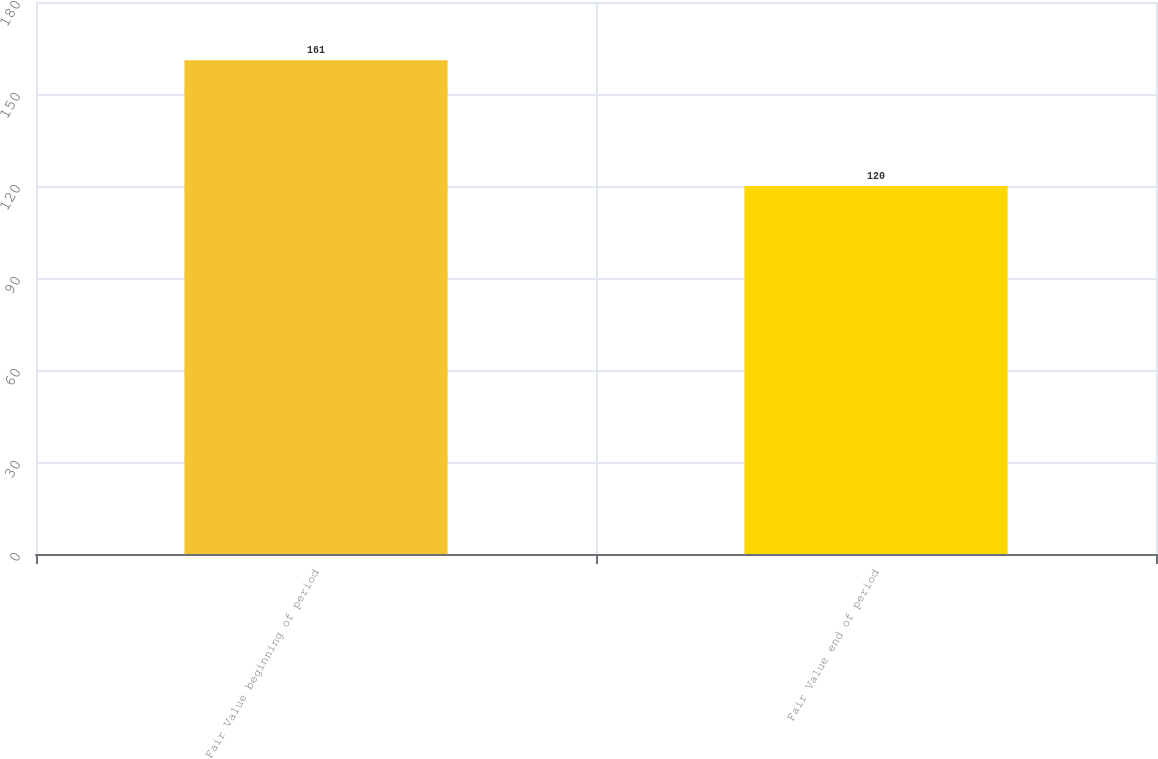Convert chart to OTSL. <chart><loc_0><loc_0><loc_500><loc_500><bar_chart><fcel>Fair Value beginning of period<fcel>Fair Value end of period<nl><fcel>161<fcel>120<nl></chart> 